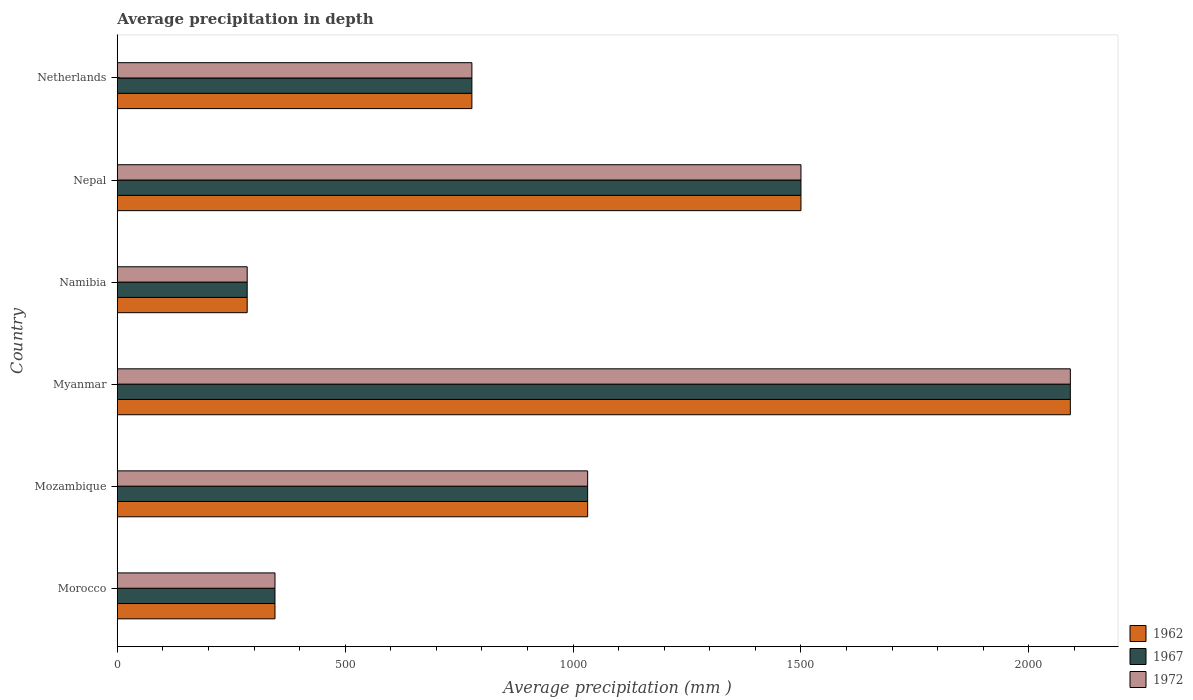Are the number of bars on each tick of the Y-axis equal?
Ensure brevity in your answer.  Yes. How many bars are there on the 4th tick from the top?
Provide a short and direct response. 3. What is the label of the 2nd group of bars from the top?
Your answer should be compact. Nepal. What is the average precipitation in 1972 in Netherlands?
Give a very brief answer. 778. Across all countries, what is the maximum average precipitation in 1962?
Your answer should be very brief. 2091. Across all countries, what is the minimum average precipitation in 1967?
Provide a short and direct response. 285. In which country was the average precipitation in 1962 maximum?
Give a very brief answer. Myanmar. In which country was the average precipitation in 1967 minimum?
Give a very brief answer. Namibia. What is the total average precipitation in 1972 in the graph?
Offer a terse response. 6032. What is the difference between the average precipitation in 1967 in Myanmar and that in Nepal?
Provide a succinct answer. 591. What is the difference between the average precipitation in 1972 in Myanmar and the average precipitation in 1967 in Mozambique?
Provide a short and direct response. 1059. What is the average average precipitation in 1967 per country?
Offer a very short reply. 1005.33. What is the ratio of the average precipitation in 1962 in Namibia to that in Netherlands?
Your response must be concise. 0.37. Is the difference between the average precipitation in 1972 in Myanmar and Netherlands greater than the difference between the average precipitation in 1962 in Myanmar and Netherlands?
Ensure brevity in your answer.  No. What is the difference between the highest and the second highest average precipitation in 1972?
Provide a short and direct response. 591. What is the difference between the highest and the lowest average precipitation in 1967?
Make the answer very short. 1806. In how many countries, is the average precipitation in 1962 greater than the average average precipitation in 1962 taken over all countries?
Offer a very short reply. 3. Is the sum of the average precipitation in 1962 in Morocco and Namibia greater than the maximum average precipitation in 1972 across all countries?
Keep it short and to the point. No. What does the 3rd bar from the top in Mozambique represents?
Your answer should be very brief. 1962. How many countries are there in the graph?
Make the answer very short. 6. Does the graph contain grids?
Your answer should be compact. No. What is the title of the graph?
Provide a succinct answer. Average precipitation in depth. What is the label or title of the X-axis?
Keep it short and to the point. Average precipitation (mm ). What is the Average precipitation (mm ) in 1962 in Morocco?
Your response must be concise. 346. What is the Average precipitation (mm ) in 1967 in Morocco?
Your response must be concise. 346. What is the Average precipitation (mm ) of 1972 in Morocco?
Your response must be concise. 346. What is the Average precipitation (mm ) of 1962 in Mozambique?
Keep it short and to the point. 1032. What is the Average precipitation (mm ) in 1967 in Mozambique?
Provide a succinct answer. 1032. What is the Average precipitation (mm ) of 1972 in Mozambique?
Your answer should be compact. 1032. What is the Average precipitation (mm ) in 1962 in Myanmar?
Provide a succinct answer. 2091. What is the Average precipitation (mm ) in 1967 in Myanmar?
Give a very brief answer. 2091. What is the Average precipitation (mm ) in 1972 in Myanmar?
Offer a terse response. 2091. What is the Average precipitation (mm ) in 1962 in Namibia?
Give a very brief answer. 285. What is the Average precipitation (mm ) of 1967 in Namibia?
Ensure brevity in your answer.  285. What is the Average precipitation (mm ) in 1972 in Namibia?
Offer a terse response. 285. What is the Average precipitation (mm ) in 1962 in Nepal?
Offer a terse response. 1500. What is the Average precipitation (mm ) in 1967 in Nepal?
Your answer should be very brief. 1500. What is the Average precipitation (mm ) in 1972 in Nepal?
Make the answer very short. 1500. What is the Average precipitation (mm ) of 1962 in Netherlands?
Your answer should be compact. 778. What is the Average precipitation (mm ) of 1967 in Netherlands?
Offer a terse response. 778. What is the Average precipitation (mm ) of 1972 in Netherlands?
Give a very brief answer. 778. Across all countries, what is the maximum Average precipitation (mm ) of 1962?
Ensure brevity in your answer.  2091. Across all countries, what is the maximum Average precipitation (mm ) in 1967?
Keep it short and to the point. 2091. Across all countries, what is the maximum Average precipitation (mm ) in 1972?
Your answer should be very brief. 2091. Across all countries, what is the minimum Average precipitation (mm ) of 1962?
Ensure brevity in your answer.  285. Across all countries, what is the minimum Average precipitation (mm ) of 1967?
Give a very brief answer. 285. Across all countries, what is the minimum Average precipitation (mm ) in 1972?
Your response must be concise. 285. What is the total Average precipitation (mm ) of 1962 in the graph?
Offer a terse response. 6032. What is the total Average precipitation (mm ) in 1967 in the graph?
Give a very brief answer. 6032. What is the total Average precipitation (mm ) of 1972 in the graph?
Offer a terse response. 6032. What is the difference between the Average precipitation (mm ) of 1962 in Morocco and that in Mozambique?
Offer a very short reply. -686. What is the difference between the Average precipitation (mm ) in 1967 in Morocco and that in Mozambique?
Your answer should be compact. -686. What is the difference between the Average precipitation (mm ) in 1972 in Morocco and that in Mozambique?
Offer a very short reply. -686. What is the difference between the Average precipitation (mm ) in 1962 in Morocco and that in Myanmar?
Your response must be concise. -1745. What is the difference between the Average precipitation (mm ) in 1967 in Morocco and that in Myanmar?
Offer a terse response. -1745. What is the difference between the Average precipitation (mm ) in 1972 in Morocco and that in Myanmar?
Provide a short and direct response. -1745. What is the difference between the Average precipitation (mm ) of 1967 in Morocco and that in Namibia?
Provide a succinct answer. 61. What is the difference between the Average precipitation (mm ) in 1962 in Morocco and that in Nepal?
Your answer should be compact. -1154. What is the difference between the Average precipitation (mm ) of 1967 in Morocco and that in Nepal?
Give a very brief answer. -1154. What is the difference between the Average precipitation (mm ) of 1972 in Morocco and that in Nepal?
Keep it short and to the point. -1154. What is the difference between the Average precipitation (mm ) in 1962 in Morocco and that in Netherlands?
Provide a succinct answer. -432. What is the difference between the Average precipitation (mm ) in 1967 in Morocco and that in Netherlands?
Offer a very short reply. -432. What is the difference between the Average precipitation (mm ) of 1972 in Morocco and that in Netherlands?
Provide a short and direct response. -432. What is the difference between the Average precipitation (mm ) in 1962 in Mozambique and that in Myanmar?
Your answer should be very brief. -1059. What is the difference between the Average precipitation (mm ) in 1967 in Mozambique and that in Myanmar?
Give a very brief answer. -1059. What is the difference between the Average precipitation (mm ) of 1972 in Mozambique and that in Myanmar?
Offer a very short reply. -1059. What is the difference between the Average precipitation (mm ) of 1962 in Mozambique and that in Namibia?
Offer a terse response. 747. What is the difference between the Average precipitation (mm ) of 1967 in Mozambique and that in Namibia?
Keep it short and to the point. 747. What is the difference between the Average precipitation (mm ) in 1972 in Mozambique and that in Namibia?
Give a very brief answer. 747. What is the difference between the Average precipitation (mm ) in 1962 in Mozambique and that in Nepal?
Keep it short and to the point. -468. What is the difference between the Average precipitation (mm ) in 1967 in Mozambique and that in Nepal?
Your response must be concise. -468. What is the difference between the Average precipitation (mm ) of 1972 in Mozambique and that in Nepal?
Offer a very short reply. -468. What is the difference between the Average precipitation (mm ) in 1962 in Mozambique and that in Netherlands?
Offer a terse response. 254. What is the difference between the Average precipitation (mm ) of 1967 in Mozambique and that in Netherlands?
Your answer should be very brief. 254. What is the difference between the Average precipitation (mm ) of 1972 in Mozambique and that in Netherlands?
Ensure brevity in your answer.  254. What is the difference between the Average precipitation (mm ) of 1962 in Myanmar and that in Namibia?
Provide a short and direct response. 1806. What is the difference between the Average precipitation (mm ) of 1967 in Myanmar and that in Namibia?
Make the answer very short. 1806. What is the difference between the Average precipitation (mm ) in 1972 in Myanmar and that in Namibia?
Provide a succinct answer. 1806. What is the difference between the Average precipitation (mm ) in 1962 in Myanmar and that in Nepal?
Keep it short and to the point. 591. What is the difference between the Average precipitation (mm ) of 1967 in Myanmar and that in Nepal?
Your answer should be very brief. 591. What is the difference between the Average precipitation (mm ) of 1972 in Myanmar and that in Nepal?
Your answer should be very brief. 591. What is the difference between the Average precipitation (mm ) in 1962 in Myanmar and that in Netherlands?
Give a very brief answer. 1313. What is the difference between the Average precipitation (mm ) in 1967 in Myanmar and that in Netherlands?
Your answer should be very brief. 1313. What is the difference between the Average precipitation (mm ) in 1972 in Myanmar and that in Netherlands?
Your answer should be very brief. 1313. What is the difference between the Average precipitation (mm ) of 1962 in Namibia and that in Nepal?
Offer a very short reply. -1215. What is the difference between the Average precipitation (mm ) in 1967 in Namibia and that in Nepal?
Your answer should be compact. -1215. What is the difference between the Average precipitation (mm ) of 1972 in Namibia and that in Nepal?
Make the answer very short. -1215. What is the difference between the Average precipitation (mm ) of 1962 in Namibia and that in Netherlands?
Your response must be concise. -493. What is the difference between the Average precipitation (mm ) of 1967 in Namibia and that in Netherlands?
Keep it short and to the point. -493. What is the difference between the Average precipitation (mm ) in 1972 in Namibia and that in Netherlands?
Provide a short and direct response. -493. What is the difference between the Average precipitation (mm ) of 1962 in Nepal and that in Netherlands?
Provide a short and direct response. 722. What is the difference between the Average precipitation (mm ) in 1967 in Nepal and that in Netherlands?
Offer a very short reply. 722. What is the difference between the Average precipitation (mm ) of 1972 in Nepal and that in Netherlands?
Your response must be concise. 722. What is the difference between the Average precipitation (mm ) of 1962 in Morocco and the Average precipitation (mm ) of 1967 in Mozambique?
Make the answer very short. -686. What is the difference between the Average precipitation (mm ) of 1962 in Morocco and the Average precipitation (mm ) of 1972 in Mozambique?
Provide a short and direct response. -686. What is the difference between the Average precipitation (mm ) of 1967 in Morocco and the Average precipitation (mm ) of 1972 in Mozambique?
Your response must be concise. -686. What is the difference between the Average precipitation (mm ) of 1962 in Morocco and the Average precipitation (mm ) of 1967 in Myanmar?
Offer a terse response. -1745. What is the difference between the Average precipitation (mm ) in 1962 in Morocco and the Average precipitation (mm ) in 1972 in Myanmar?
Your answer should be very brief. -1745. What is the difference between the Average precipitation (mm ) in 1967 in Morocco and the Average precipitation (mm ) in 1972 in Myanmar?
Make the answer very short. -1745. What is the difference between the Average precipitation (mm ) of 1967 in Morocco and the Average precipitation (mm ) of 1972 in Namibia?
Provide a short and direct response. 61. What is the difference between the Average precipitation (mm ) of 1962 in Morocco and the Average precipitation (mm ) of 1967 in Nepal?
Offer a very short reply. -1154. What is the difference between the Average precipitation (mm ) of 1962 in Morocco and the Average precipitation (mm ) of 1972 in Nepal?
Provide a succinct answer. -1154. What is the difference between the Average precipitation (mm ) in 1967 in Morocco and the Average precipitation (mm ) in 1972 in Nepal?
Your answer should be very brief. -1154. What is the difference between the Average precipitation (mm ) of 1962 in Morocco and the Average precipitation (mm ) of 1967 in Netherlands?
Make the answer very short. -432. What is the difference between the Average precipitation (mm ) of 1962 in Morocco and the Average precipitation (mm ) of 1972 in Netherlands?
Ensure brevity in your answer.  -432. What is the difference between the Average precipitation (mm ) of 1967 in Morocco and the Average precipitation (mm ) of 1972 in Netherlands?
Ensure brevity in your answer.  -432. What is the difference between the Average precipitation (mm ) of 1962 in Mozambique and the Average precipitation (mm ) of 1967 in Myanmar?
Provide a short and direct response. -1059. What is the difference between the Average precipitation (mm ) of 1962 in Mozambique and the Average precipitation (mm ) of 1972 in Myanmar?
Keep it short and to the point. -1059. What is the difference between the Average precipitation (mm ) of 1967 in Mozambique and the Average precipitation (mm ) of 1972 in Myanmar?
Keep it short and to the point. -1059. What is the difference between the Average precipitation (mm ) of 1962 in Mozambique and the Average precipitation (mm ) of 1967 in Namibia?
Your response must be concise. 747. What is the difference between the Average precipitation (mm ) in 1962 in Mozambique and the Average precipitation (mm ) in 1972 in Namibia?
Your response must be concise. 747. What is the difference between the Average precipitation (mm ) in 1967 in Mozambique and the Average precipitation (mm ) in 1972 in Namibia?
Provide a succinct answer. 747. What is the difference between the Average precipitation (mm ) of 1962 in Mozambique and the Average precipitation (mm ) of 1967 in Nepal?
Provide a succinct answer. -468. What is the difference between the Average precipitation (mm ) of 1962 in Mozambique and the Average precipitation (mm ) of 1972 in Nepal?
Provide a short and direct response. -468. What is the difference between the Average precipitation (mm ) of 1967 in Mozambique and the Average precipitation (mm ) of 1972 in Nepal?
Offer a very short reply. -468. What is the difference between the Average precipitation (mm ) in 1962 in Mozambique and the Average precipitation (mm ) in 1967 in Netherlands?
Your answer should be compact. 254. What is the difference between the Average precipitation (mm ) of 1962 in Mozambique and the Average precipitation (mm ) of 1972 in Netherlands?
Provide a succinct answer. 254. What is the difference between the Average precipitation (mm ) in 1967 in Mozambique and the Average precipitation (mm ) in 1972 in Netherlands?
Provide a succinct answer. 254. What is the difference between the Average precipitation (mm ) in 1962 in Myanmar and the Average precipitation (mm ) in 1967 in Namibia?
Your answer should be very brief. 1806. What is the difference between the Average precipitation (mm ) of 1962 in Myanmar and the Average precipitation (mm ) of 1972 in Namibia?
Your response must be concise. 1806. What is the difference between the Average precipitation (mm ) of 1967 in Myanmar and the Average precipitation (mm ) of 1972 in Namibia?
Provide a succinct answer. 1806. What is the difference between the Average precipitation (mm ) of 1962 in Myanmar and the Average precipitation (mm ) of 1967 in Nepal?
Ensure brevity in your answer.  591. What is the difference between the Average precipitation (mm ) in 1962 in Myanmar and the Average precipitation (mm ) in 1972 in Nepal?
Give a very brief answer. 591. What is the difference between the Average precipitation (mm ) in 1967 in Myanmar and the Average precipitation (mm ) in 1972 in Nepal?
Provide a succinct answer. 591. What is the difference between the Average precipitation (mm ) in 1962 in Myanmar and the Average precipitation (mm ) in 1967 in Netherlands?
Ensure brevity in your answer.  1313. What is the difference between the Average precipitation (mm ) in 1962 in Myanmar and the Average precipitation (mm ) in 1972 in Netherlands?
Make the answer very short. 1313. What is the difference between the Average precipitation (mm ) in 1967 in Myanmar and the Average precipitation (mm ) in 1972 in Netherlands?
Offer a terse response. 1313. What is the difference between the Average precipitation (mm ) of 1962 in Namibia and the Average precipitation (mm ) of 1967 in Nepal?
Your answer should be very brief. -1215. What is the difference between the Average precipitation (mm ) of 1962 in Namibia and the Average precipitation (mm ) of 1972 in Nepal?
Provide a succinct answer. -1215. What is the difference between the Average precipitation (mm ) in 1967 in Namibia and the Average precipitation (mm ) in 1972 in Nepal?
Provide a short and direct response. -1215. What is the difference between the Average precipitation (mm ) in 1962 in Namibia and the Average precipitation (mm ) in 1967 in Netherlands?
Keep it short and to the point. -493. What is the difference between the Average precipitation (mm ) of 1962 in Namibia and the Average precipitation (mm ) of 1972 in Netherlands?
Keep it short and to the point. -493. What is the difference between the Average precipitation (mm ) of 1967 in Namibia and the Average precipitation (mm ) of 1972 in Netherlands?
Provide a short and direct response. -493. What is the difference between the Average precipitation (mm ) in 1962 in Nepal and the Average precipitation (mm ) in 1967 in Netherlands?
Ensure brevity in your answer.  722. What is the difference between the Average precipitation (mm ) of 1962 in Nepal and the Average precipitation (mm ) of 1972 in Netherlands?
Provide a succinct answer. 722. What is the difference between the Average precipitation (mm ) in 1967 in Nepal and the Average precipitation (mm ) in 1972 in Netherlands?
Offer a terse response. 722. What is the average Average precipitation (mm ) in 1962 per country?
Ensure brevity in your answer.  1005.33. What is the average Average precipitation (mm ) in 1967 per country?
Ensure brevity in your answer.  1005.33. What is the average Average precipitation (mm ) in 1972 per country?
Keep it short and to the point. 1005.33. What is the difference between the Average precipitation (mm ) of 1962 and Average precipitation (mm ) of 1972 in Morocco?
Give a very brief answer. 0. What is the difference between the Average precipitation (mm ) of 1962 and Average precipitation (mm ) of 1972 in Mozambique?
Your answer should be very brief. 0. What is the difference between the Average precipitation (mm ) in 1962 and Average precipitation (mm ) in 1967 in Myanmar?
Ensure brevity in your answer.  0. What is the difference between the Average precipitation (mm ) of 1962 and Average precipitation (mm ) of 1972 in Myanmar?
Offer a terse response. 0. What is the difference between the Average precipitation (mm ) in 1967 and Average precipitation (mm ) in 1972 in Myanmar?
Your response must be concise. 0. What is the difference between the Average precipitation (mm ) in 1962 and Average precipitation (mm ) in 1967 in Namibia?
Make the answer very short. 0. What is the difference between the Average precipitation (mm ) in 1962 and Average precipitation (mm ) in 1967 in Nepal?
Your answer should be compact. 0. What is the difference between the Average precipitation (mm ) in 1967 and Average precipitation (mm ) in 1972 in Nepal?
Provide a short and direct response. 0. What is the ratio of the Average precipitation (mm ) in 1962 in Morocco to that in Mozambique?
Offer a terse response. 0.34. What is the ratio of the Average precipitation (mm ) of 1967 in Morocco to that in Mozambique?
Your answer should be very brief. 0.34. What is the ratio of the Average precipitation (mm ) in 1972 in Morocco to that in Mozambique?
Offer a terse response. 0.34. What is the ratio of the Average precipitation (mm ) of 1962 in Morocco to that in Myanmar?
Offer a very short reply. 0.17. What is the ratio of the Average precipitation (mm ) of 1967 in Morocco to that in Myanmar?
Offer a very short reply. 0.17. What is the ratio of the Average precipitation (mm ) of 1972 in Morocco to that in Myanmar?
Your answer should be very brief. 0.17. What is the ratio of the Average precipitation (mm ) of 1962 in Morocco to that in Namibia?
Your answer should be compact. 1.21. What is the ratio of the Average precipitation (mm ) in 1967 in Morocco to that in Namibia?
Offer a very short reply. 1.21. What is the ratio of the Average precipitation (mm ) in 1972 in Morocco to that in Namibia?
Offer a very short reply. 1.21. What is the ratio of the Average precipitation (mm ) in 1962 in Morocco to that in Nepal?
Offer a very short reply. 0.23. What is the ratio of the Average precipitation (mm ) of 1967 in Morocco to that in Nepal?
Make the answer very short. 0.23. What is the ratio of the Average precipitation (mm ) of 1972 in Morocco to that in Nepal?
Your response must be concise. 0.23. What is the ratio of the Average precipitation (mm ) of 1962 in Morocco to that in Netherlands?
Provide a succinct answer. 0.44. What is the ratio of the Average precipitation (mm ) of 1967 in Morocco to that in Netherlands?
Give a very brief answer. 0.44. What is the ratio of the Average precipitation (mm ) in 1972 in Morocco to that in Netherlands?
Provide a succinct answer. 0.44. What is the ratio of the Average precipitation (mm ) of 1962 in Mozambique to that in Myanmar?
Ensure brevity in your answer.  0.49. What is the ratio of the Average precipitation (mm ) of 1967 in Mozambique to that in Myanmar?
Your response must be concise. 0.49. What is the ratio of the Average precipitation (mm ) in 1972 in Mozambique to that in Myanmar?
Offer a very short reply. 0.49. What is the ratio of the Average precipitation (mm ) in 1962 in Mozambique to that in Namibia?
Make the answer very short. 3.62. What is the ratio of the Average precipitation (mm ) in 1967 in Mozambique to that in Namibia?
Your answer should be very brief. 3.62. What is the ratio of the Average precipitation (mm ) in 1972 in Mozambique to that in Namibia?
Your response must be concise. 3.62. What is the ratio of the Average precipitation (mm ) of 1962 in Mozambique to that in Nepal?
Your answer should be compact. 0.69. What is the ratio of the Average precipitation (mm ) of 1967 in Mozambique to that in Nepal?
Offer a terse response. 0.69. What is the ratio of the Average precipitation (mm ) in 1972 in Mozambique to that in Nepal?
Provide a short and direct response. 0.69. What is the ratio of the Average precipitation (mm ) in 1962 in Mozambique to that in Netherlands?
Your answer should be compact. 1.33. What is the ratio of the Average precipitation (mm ) of 1967 in Mozambique to that in Netherlands?
Provide a succinct answer. 1.33. What is the ratio of the Average precipitation (mm ) in 1972 in Mozambique to that in Netherlands?
Offer a terse response. 1.33. What is the ratio of the Average precipitation (mm ) in 1962 in Myanmar to that in Namibia?
Make the answer very short. 7.34. What is the ratio of the Average precipitation (mm ) in 1967 in Myanmar to that in Namibia?
Offer a very short reply. 7.34. What is the ratio of the Average precipitation (mm ) in 1972 in Myanmar to that in Namibia?
Provide a short and direct response. 7.34. What is the ratio of the Average precipitation (mm ) of 1962 in Myanmar to that in Nepal?
Your answer should be compact. 1.39. What is the ratio of the Average precipitation (mm ) in 1967 in Myanmar to that in Nepal?
Offer a very short reply. 1.39. What is the ratio of the Average precipitation (mm ) of 1972 in Myanmar to that in Nepal?
Make the answer very short. 1.39. What is the ratio of the Average precipitation (mm ) of 1962 in Myanmar to that in Netherlands?
Provide a succinct answer. 2.69. What is the ratio of the Average precipitation (mm ) of 1967 in Myanmar to that in Netherlands?
Ensure brevity in your answer.  2.69. What is the ratio of the Average precipitation (mm ) of 1972 in Myanmar to that in Netherlands?
Offer a terse response. 2.69. What is the ratio of the Average precipitation (mm ) of 1962 in Namibia to that in Nepal?
Provide a succinct answer. 0.19. What is the ratio of the Average precipitation (mm ) in 1967 in Namibia to that in Nepal?
Keep it short and to the point. 0.19. What is the ratio of the Average precipitation (mm ) in 1972 in Namibia to that in Nepal?
Keep it short and to the point. 0.19. What is the ratio of the Average precipitation (mm ) of 1962 in Namibia to that in Netherlands?
Your answer should be compact. 0.37. What is the ratio of the Average precipitation (mm ) in 1967 in Namibia to that in Netherlands?
Provide a short and direct response. 0.37. What is the ratio of the Average precipitation (mm ) in 1972 in Namibia to that in Netherlands?
Offer a terse response. 0.37. What is the ratio of the Average precipitation (mm ) of 1962 in Nepal to that in Netherlands?
Provide a short and direct response. 1.93. What is the ratio of the Average precipitation (mm ) in 1967 in Nepal to that in Netherlands?
Provide a short and direct response. 1.93. What is the ratio of the Average precipitation (mm ) of 1972 in Nepal to that in Netherlands?
Your response must be concise. 1.93. What is the difference between the highest and the second highest Average precipitation (mm ) in 1962?
Provide a short and direct response. 591. What is the difference between the highest and the second highest Average precipitation (mm ) in 1967?
Provide a short and direct response. 591. What is the difference between the highest and the second highest Average precipitation (mm ) in 1972?
Ensure brevity in your answer.  591. What is the difference between the highest and the lowest Average precipitation (mm ) in 1962?
Your answer should be very brief. 1806. What is the difference between the highest and the lowest Average precipitation (mm ) in 1967?
Ensure brevity in your answer.  1806. What is the difference between the highest and the lowest Average precipitation (mm ) of 1972?
Provide a succinct answer. 1806. 